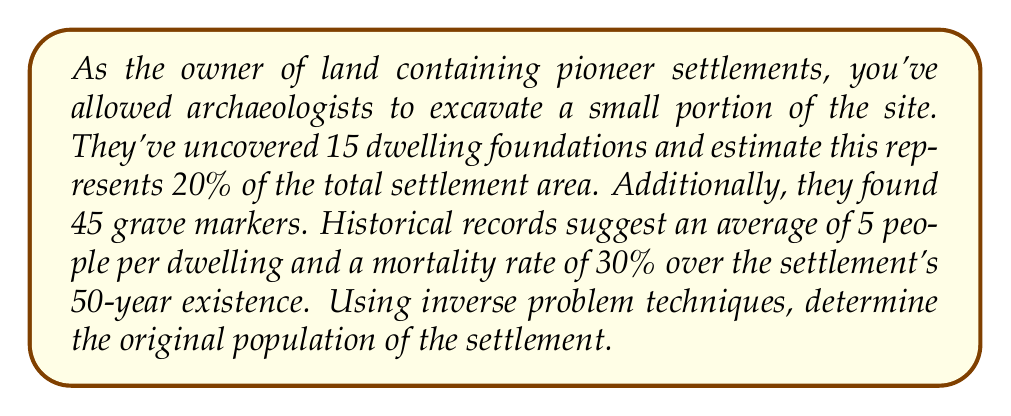Could you help me with this problem? Let's approach this step-by-step:

1) First, we need to estimate the total number of dwellings:
   - 15 dwellings represent 20% of the total
   - Let $x$ be the total number of dwellings
   - $15 = 0.20x$
   - $x = 15 / 0.20 = 75$ dwellings in total

2) Now, let's estimate the population based on dwellings:
   - Average of 5 people per dwelling
   - Population = $75 \times 5 = 375$ people

3) Next, we'll use the grave markers to verify our estimate:
   - 45 grave markers found
   - This represents 30% of the original population over 50 years
   - Let $y$ be the original population
   - $45 = 0.30y$
   - $y = 45 / 0.30 = 150$ people

4) We now have two different estimates: 375 and 150
   - The discrepancy suggests we need to refine our model

5) Let's consider that the grave markers might not represent all deaths:
   - If 150 is 30% of the population, the total would be 500
   - This is closer to our dwelling-based estimate of 375

6) We can use a weighted average of our estimates:
   - Give more weight to the dwelling estimate as it's based on physical evidence
   - Let's use a 2:1 ratio: $\frac{2(375) + 150}{3} = 300$

7) Rounding to the nearest 50 for a reasonable estimate:
   $300 \approx 300$ people
Answer: 300 people 